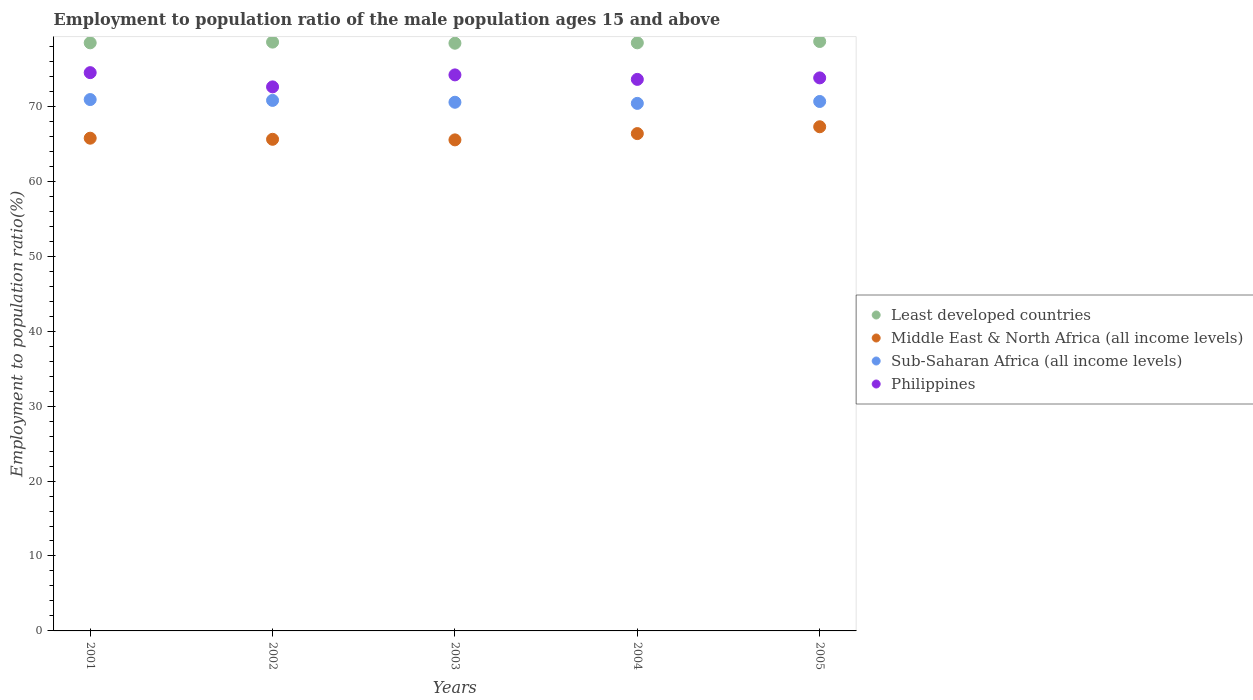Is the number of dotlines equal to the number of legend labels?
Offer a terse response. Yes. What is the employment to population ratio in Philippines in 2005?
Offer a terse response. 73.8. Across all years, what is the maximum employment to population ratio in Sub-Saharan Africa (all income levels)?
Ensure brevity in your answer.  70.91. Across all years, what is the minimum employment to population ratio in Middle East & North Africa (all income levels)?
Keep it short and to the point. 65.53. In which year was the employment to population ratio in Sub-Saharan Africa (all income levels) maximum?
Your answer should be very brief. 2001. What is the total employment to population ratio in Least developed countries in the graph?
Offer a very short reply. 392.61. What is the difference between the employment to population ratio in Least developed countries in 2001 and that in 2003?
Your answer should be compact. 0.05. What is the difference between the employment to population ratio in Middle East & North Africa (all income levels) in 2002 and the employment to population ratio in Philippines in 2001?
Offer a very short reply. -8.9. What is the average employment to population ratio in Sub-Saharan Africa (all income levels) per year?
Provide a short and direct response. 70.66. In the year 2002, what is the difference between the employment to population ratio in Middle East & North Africa (all income levels) and employment to population ratio in Sub-Saharan Africa (all income levels)?
Provide a succinct answer. -5.19. In how many years, is the employment to population ratio in Philippines greater than 66 %?
Your response must be concise. 5. What is the ratio of the employment to population ratio in Middle East & North Africa (all income levels) in 2003 to that in 2004?
Make the answer very short. 0.99. Is the employment to population ratio in Philippines in 2002 less than that in 2003?
Offer a terse response. Yes. Is the difference between the employment to population ratio in Middle East & North Africa (all income levels) in 2003 and 2004 greater than the difference between the employment to population ratio in Sub-Saharan Africa (all income levels) in 2003 and 2004?
Offer a very short reply. No. What is the difference between the highest and the second highest employment to population ratio in Philippines?
Your answer should be compact. 0.3. What is the difference between the highest and the lowest employment to population ratio in Least developed countries?
Offer a terse response. 0.23. In how many years, is the employment to population ratio in Middle East & North Africa (all income levels) greater than the average employment to population ratio in Middle East & North Africa (all income levels) taken over all years?
Give a very brief answer. 2. Is the sum of the employment to population ratio in Least developed countries in 2002 and 2004 greater than the maximum employment to population ratio in Middle East & North Africa (all income levels) across all years?
Provide a succinct answer. Yes. Is it the case that in every year, the sum of the employment to population ratio in Philippines and employment to population ratio in Middle East & North Africa (all income levels)  is greater than the sum of employment to population ratio in Least developed countries and employment to population ratio in Sub-Saharan Africa (all income levels)?
Offer a very short reply. No. Is it the case that in every year, the sum of the employment to population ratio in Philippines and employment to population ratio in Least developed countries  is greater than the employment to population ratio in Sub-Saharan Africa (all income levels)?
Your answer should be compact. Yes. Is the employment to population ratio in Philippines strictly greater than the employment to population ratio in Sub-Saharan Africa (all income levels) over the years?
Keep it short and to the point. Yes. Is the employment to population ratio in Sub-Saharan Africa (all income levels) strictly less than the employment to population ratio in Least developed countries over the years?
Make the answer very short. Yes. Does the graph contain any zero values?
Give a very brief answer. No. How many legend labels are there?
Make the answer very short. 4. How are the legend labels stacked?
Make the answer very short. Vertical. What is the title of the graph?
Your response must be concise. Employment to population ratio of the male population ages 15 and above. Does "Dominican Republic" appear as one of the legend labels in the graph?
Your answer should be compact. No. What is the label or title of the X-axis?
Give a very brief answer. Years. What is the Employment to population ratio(%) of Least developed countries in 2001?
Offer a very short reply. 78.48. What is the Employment to population ratio(%) of Middle East & North Africa (all income levels) in 2001?
Keep it short and to the point. 65.75. What is the Employment to population ratio(%) in Sub-Saharan Africa (all income levels) in 2001?
Provide a short and direct response. 70.91. What is the Employment to population ratio(%) of Philippines in 2001?
Ensure brevity in your answer.  74.5. What is the Employment to population ratio(%) in Least developed countries in 2002?
Keep it short and to the point. 78.57. What is the Employment to population ratio(%) in Middle East & North Africa (all income levels) in 2002?
Your answer should be compact. 65.6. What is the Employment to population ratio(%) in Sub-Saharan Africa (all income levels) in 2002?
Give a very brief answer. 70.8. What is the Employment to population ratio(%) in Philippines in 2002?
Ensure brevity in your answer.  72.6. What is the Employment to population ratio(%) in Least developed countries in 2003?
Offer a very short reply. 78.43. What is the Employment to population ratio(%) in Middle East & North Africa (all income levels) in 2003?
Your response must be concise. 65.53. What is the Employment to population ratio(%) in Sub-Saharan Africa (all income levels) in 2003?
Your answer should be very brief. 70.55. What is the Employment to population ratio(%) of Philippines in 2003?
Your response must be concise. 74.2. What is the Employment to population ratio(%) in Least developed countries in 2004?
Offer a terse response. 78.48. What is the Employment to population ratio(%) in Middle East & North Africa (all income levels) in 2004?
Your answer should be compact. 66.37. What is the Employment to population ratio(%) in Sub-Saharan Africa (all income levels) in 2004?
Your answer should be compact. 70.4. What is the Employment to population ratio(%) in Philippines in 2004?
Provide a succinct answer. 73.6. What is the Employment to population ratio(%) in Least developed countries in 2005?
Give a very brief answer. 78.66. What is the Employment to population ratio(%) of Middle East & North Africa (all income levels) in 2005?
Keep it short and to the point. 67.28. What is the Employment to population ratio(%) of Sub-Saharan Africa (all income levels) in 2005?
Your answer should be very brief. 70.65. What is the Employment to population ratio(%) in Philippines in 2005?
Offer a terse response. 73.8. Across all years, what is the maximum Employment to population ratio(%) in Least developed countries?
Your answer should be compact. 78.66. Across all years, what is the maximum Employment to population ratio(%) of Middle East & North Africa (all income levels)?
Provide a short and direct response. 67.28. Across all years, what is the maximum Employment to population ratio(%) in Sub-Saharan Africa (all income levels)?
Offer a terse response. 70.91. Across all years, what is the maximum Employment to population ratio(%) in Philippines?
Provide a succinct answer. 74.5. Across all years, what is the minimum Employment to population ratio(%) of Least developed countries?
Make the answer very short. 78.43. Across all years, what is the minimum Employment to population ratio(%) in Middle East & North Africa (all income levels)?
Your answer should be compact. 65.53. Across all years, what is the minimum Employment to population ratio(%) of Sub-Saharan Africa (all income levels)?
Your answer should be compact. 70.4. Across all years, what is the minimum Employment to population ratio(%) in Philippines?
Give a very brief answer. 72.6. What is the total Employment to population ratio(%) in Least developed countries in the graph?
Provide a succinct answer. 392.61. What is the total Employment to population ratio(%) of Middle East & North Africa (all income levels) in the graph?
Ensure brevity in your answer.  330.53. What is the total Employment to population ratio(%) of Sub-Saharan Africa (all income levels) in the graph?
Keep it short and to the point. 353.3. What is the total Employment to population ratio(%) in Philippines in the graph?
Make the answer very short. 368.7. What is the difference between the Employment to population ratio(%) in Least developed countries in 2001 and that in 2002?
Keep it short and to the point. -0.1. What is the difference between the Employment to population ratio(%) in Middle East & North Africa (all income levels) in 2001 and that in 2002?
Keep it short and to the point. 0.15. What is the difference between the Employment to population ratio(%) of Sub-Saharan Africa (all income levels) in 2001 and that in 2002?
Provide a succinct answer. 0.11. What is the difference between the Employment to population ratio(%) of Philippines in 2001 and that in 2002?
Keep it short and to the point. 1.9. What is the difference between the Employment to population ratio(%) of Least developed countries in 2001 and that in 2003?
Offer a terse response. 0.05. What is the difference between the Employment to population ratio(%) in Middle East & North Africa (all income levels) in 2001 and that in 2003?
Make the answer very short. 0.22. What is the difference between the Employment to population ratio(%) in Sub-Saharan Africa (all income levels) in 2001 and that in 2003?
Ensure brevity in your answer.  0.36. What is the difference between the Employment to population ratio(%) in Philippines in 2001 and that in 2003?
Ensure brevity in your answer.  0.3. What is the difference between the Employment to population ratio(%) in Least developed countries in 2001 and that in 2004?
Give a very brief answer. -0. What is the difference between the Employment to population ratio(%) in Middle East & North Africa (all income levels) in 2001 and that in 2004?
Make the answer very short. -0.61. What is the difference between the Employment to population ratio(%) in Sub-Saharan Africa (all income levels) in 2001 and that in 2004?
Make the answer very short. 0.51. What is the difference between the Employment to population ratio(%) in Least developed countries in 2001 and that in 2005?
Offer a terse response. -0.18. What is the difference between the Employment to population ratio(%) of Middle East & North Africa (all income levels) in 2001 and that in 2005?
Your response must be concise. -1.53. What is the difference between the Employment to population ratio(%) of Sub-Saharan Africa (all income levels) in 2001 and that in 2005?
Your answer should be very brief. 0.26. What is the difference between the Employment to population ratio(%) of Philippines in 2001 and that in 2005?
Make the answer very short. 0.7. What is the difference between the Employment to population ratio(%) in Least developed countries in 2002 and that in 2003?
Give a very brief answer. 0.15. What is the difference between the Employment to population ratio(%) of Middle East & North Africa (all income levels) in 2002 and that in 2003?
Make the answer very short. 0.08. What is the difference between the Employment to population ratio(%) of Sub-Saharan Africa (all income levels) in 2002 and that in 2003?
Provide a short and direct response. 0.25. What is the difference between the Employment to population ratio(%) of Least developed countries in 2002 and that in 2004?
Offer a terse response. 0.1. What is the difference between the Employment to population ratio(%) of Middle East & North Africa (all income levels) in 2002 and that in 2004?
Offer a very short reply. -0.76. What is the difference between the Employment to population ratio(%) in Sub-Saharan Africa (all income levels) in 2002 and that in 2004?
Offer a terse response. 0.4. What is the difference between the Employment to population ratio(%) of Philippines in 2002 and that in 2004?
Your answer should be very brief. -1. What is the difference between the Employment to population ratio(%) of Least developed countries in 2002 and that in 2005?
Keep it short and to the point. -0.08. What is the difference between the Employment to population ratio(%) of Middle East & North Africa (all income levels) in 2002 and that in 2005?
Keep it short and to the point. -1.67. What is the difference between the Employment to population ratio(%) in Sub-Saharan Africa (all income levels) in 2002 and that in 2005?
Provide a short and direct response. 0.14. What is the difference between the Employment to population ratio(%) of Philippines in 2002 and that in 2005?
Offer a very short reply. -1.2. What is the difference between the Employment to population ratio(%) in Least developed countries in 2003 and that in 2004?
Provide a succinct answer. -0.05. What is the difference between the Employment to population ratio(%) in Middle East & North Africa (all income levels) in 2003 and that in 2004?
Provide a succinct answer. -0.84. What is the difference between the Employment to population ratio(%) of Least developed countries in 2003 and that in 2005?
Provide a succinct answer. -0.23. What is the difference between the Employment to population ratio(%) of Middle East & North Africa (all income levels) in 2003 and that in 2005?
Offer a very short reply. -1.75. What is the difference between the Employment to population ratio(%) in Sub-Saharan Africa (all income levels) in 2003 and that in 2005?
Give a very brief answer. -0.1. What is the difference between the Employment to population ratio(%) in Philippines in 2003 and that in 2005?
Offer a very short reply. 0.4. What is the difference between the Employment to population ratio(%) in Least developed countries in 2004 and that in 2005?
Offer a terse response. -0.18. What is the difference between the Employment to population ratio(%) of Middle East & North Africa (all income levels) in 2004 and that in 2005?
Your answer should be very brief. -0.91. What is the difference between the Employment to population ratio(%) of Sub-Saharan Africa (all income levels) in 2004 and that in 2005?
Ensure brevity in your answer.  -0.25. What is the difference between the Employment to population ratio(%) in Least developed countries in 2001 and the Employment to population ratio(%) in Middle East & North Africa (all income levels) in 2002?
Your answer should be compact. 12.87. What is the difference between the Employment to population ratio(%) of Least developed countries in 2001 and the Employment to population ratio(%) of Sub-Saharan Africa (all income levels) in 2002?
Offer a terse response. 7.68. What is the difference between the Employment to population ratio(%) of Least developed countries in 2001 and the Employment to population ratio(%) of Philippines in 2002?
Offer a terse response. 5.88. What is the difference between the Employment to population ratio(%) of Middle East & North Africa (all income levels) in 2001 and the Employment to population ratio(%) of Sub-Saharan Africa (all income levels) in 2002?
Ensure brevity in your answer.  -5.04. What is the difference between the Employment to population ratio(%) of Middle East & North Africa (all income levels) in 2001 and the Employment to population ratio(%) of Philippines in 2002?
Give a very brief answer. -6.85. What is the difference between the Employment to population ratio(%) in Sub-Saharan Africa (all income levels) in 2001 and the Employment to population ratio(%) in Philippines in 2002?
Keep it short and to the point. -1.69. What is the difference between the Employment to population ratio(%) of Least developed countries in 2001 and the Employment to population ratio(%) of Middle East & North Africa (all income levels) in 2003?
Offer a very short reply. 12.95. What is the difference between the Employment to population ratio(%) in Least developed countries in 2001 and the Employment to population ratio(%) in Sub-Saharan Africa (all income levels) in 2003?
Give a very brief answer. 7.93. What is the difference between the Employment to population ratio(%) in Least developed countries in 2001 and the Employment to population ratio(%) in Philippines in 2003?
Keep it short and to the point. 4.28. What is the difference between the Employment to population ratio(%) of Middle East & North Africa (all income levels) in 2001 and the Employment to population ratio(%) of Sub-Saharan Africa (all income levels) in 2003?
Offer a terse response. -4.8. What is the difference between the Employment to population ratio(%) of Middle East & North Africa (all income levels) in 2001 and the Employment to population ratio(%) of Philippines in 2003?
Give a very brief answer. -8.45. What is the difference between the Employment to population ratio(%) in Sub-Saharan Africa (all income levels) in 2001 and the Employment to population ratio(%) in Philippines in 2003?
Ensure brevity in your answer.  -3.29. What is the difference between the Employment to population ratio(%) in Least developed countries in 2001 and the Employment to population ratio(%) in Middle East & North Africa (all income levels) in 2004?
Offer a terse response. 12.11. What is the difference between the Employment to population ratio(%) of Least developed countries in 2001 and the Employment to population ratio(%) of Sub-Saharan Africa (all income levels) in 2004?
Your answer should be very brief. 8.08. What is the difference between the Employment to population ratio(%) in Least developed countries in 2001 and the Employment to population ratio(%) in Philippines in 2004?
Your answer should be very brief. 4.88. What is the difference between the Employment to population ratio(%) in Middle East & North Africa (all income levels) in 2001 and the Employment to population ratio(%) in Sub-Saharan Africa (all income levels) in 2004?
Offer a very short reply. -4.65. What is the difference between the Employment to population ratio(%) in Middle East & North Africa (all income levels) in 2001 and the Employment to population ratio(%) in Philippines in 2004?
Provide a succinct answer. -7.85. What is the difference between the Employment to population ratio(%) of Sub-Saharan Africa (all income levels) in 2001 and the Employment to population ratio(%) of Philippines in 2004?
Ensure brevity in your answer.  -2.69. What is the difference between the Employment to population ratio(%) of Least developed countries in 2001 and the Employment to population ratio(%) of Middle East & North Africa (all income levels) in 2005?
Provide a succinct answer. 11.2. What is the difference between the Employment to population ratio(%) of Least developed countries in 2001 and the Employment to population ratio(%) of Sub-Saharan Africa (all income levels) in 2005?
Ensure brevity in your answer.  7.83. What is the difference between the Employment to population ratio(%) of Least developed countries in 2001 and the Employment to population ratio(%) of Philippines in 2005?
Make the answer very short. 4.68. What is the difference between the Employment to population ratio(%) of Middle East & North Africa (all income levels) in 2001 and the Employment to population ratio(%) of Sub-Saharan Africa (all income levels) in 2005?
Offer a terse response. -4.9. What is the difference between the Employment to population ratio(%) of Middle East & North Africa (all income levels) in 2001 and the Employment to population ratio(%) of Philippines in 2005?
Your response must be concise. -8.05. What is the difference between the Employment to population ratio(%) in Sub-Saharan Africa (all income levels) in 2001 and the Employment to population ratio(%) in Philippines in 2005?
Your answer should be very brief. -2.89. What is the difference between the Employment to population ratio(%) of Least developed countries in 2002 and the Employment to population ratio(%) of Middle East & North Africa (all income levels) in 2003?
Offer a terse response. 13.05. What is the difference between the Employment to population ratio(%) in Least developed countries in 2002 and the Employment to population ratio(%) in Sub-Saharan Africa (all income levels) in 2003?
Your answer should be compact. 8.03. What is the difference between the Employment to population ratio(%) in Least developed countries in 2002 and the Employment to population ratio(%) in Philippines in 2003?
Provide a succinct answer. 4.37. What is the difference between the Employment to population ratio(%) in Middle East & North Africa (all income levels) in 2002 and the Employment to population ratio(%) in Sub-Saharan Africa (all income levels) in 2003?
Your response must be concise. -4.94. What is the difference between the Employment to population ratio(%) of Middle East & North Africa (all income levels) in 2002 and the Employment to population ratio(%) of Philippines in 2003?
Provide a short and direct response. -8.6. What is the difference between the Employment to population ratio(%) in Sub-Saharan Africa (all income levels) in 2002 and the Employment to population ratio(%) in Philippines in 2003?
Offer a terse response. -3.4. What is the difference between the Employment to population ratio(%) of Least developed countries in 2002 and the Employment to population ratio(%) of Middle East & North Africa (all income levels) in 2004?
Make the answer very short. 12.21. What is the difference between the Employment to population ratio(%) of Least developed countries in 2002 and the Employment to population ratio(%) of Sub-Saharan Africa (all income levels) in 2004?
Make the answer very short. 8.18. What is the difference between the Employment to population ratio(%) in Least developed countries in 2002 and the Employment to population ratio(%) in Philippines in 2004?
Your response must be concise. 4.97. What is the difference between the Employment to population ratio(%) of Middle East & North Africa (all income levels) in 2002 and the Employment to population ratio(%) of Sub-Saharan Africa (all income levels) in 2004?
Make the answer very short. -4.79. What is the difference between the Employment to population ratio(%) of Middle East & North Africa (all income levels) in 2002 and the Employment to population ratio(%) of Philippines in 2004?
Make the answer very short. -8. What is the difference between the Employment to population ratio(%) of Sub-Saharan Africa (all income levels) in 2002 and the Employment to population ratio(%) of Philippines in 2004?
Your answer should be very brief. -2.8. What is the difference between the Employment to population ratio(%) in Least developed countries in 2002 and the Employment to population ratio(%) in Middle East & North Africa (all income levels) in 2005?
Provide a short and direct response. 11.3. What is the difference between the Employment to population ratio(%) of Least developed countries in 2002 and the Employment to population ratio(%) of Sub-Saharan Africa (all income levels) in 2005?
Your answer should be very brief. 7.92. What is the difference between the Employment to population ratio(%) in Least developed countries in 2002 and the Employment to population ratio(%) in Philippines in 2005?
Your response must be concise. 4.77. What is the difference between the Employment to population ratio(%) in Middle East & North Africa (all income levels) in 2002 and the Employment to population ratio(%) in Sub-Saharan Africa (all income levels) in 2005?
Provide a succinct answer. -5.05. What is the difference between the Employment to population ratio(%) of Middle East & North Africa (all income levels) in 2002 and the Employment to population ratio(%) of Philippines in 2005?
Offer a very short reply. -8.2. What is the difference between the Employment to population ratio(%) in Sub-Saharan Africa (all income levels) in 2002 and the Employment to population ratio(%) in Philippines in 2005?
Your answer should be compact. -3. What is the difference between the Employment to population ratio(%) in Least developed countries in 2003 and the Employment to population ratio(%) in Middle East & North Africa (all income levels) in 2004?
Ensure brevity in your answer.  12.06. What is the difference between the Employment to population ratio(%) of Least developed countries in 2003 and the Employment to population ratio(%) of Sub-Saharan Africa (all income levels) in 2004?
Provide a short and direct response. 8.03. What is the difference between the Employment to population ratio(%) in Least developed countries in 2003 and the Employment to population ratio(%) in Philippines in 2004?
Your response must be concise. 4.83. What is the difference between the Employment to population ratio(%) of Middle East & North Africa (all income levels) in 2003 and the Employment to population ratio(%) of Sub-Saharan Africa (all income levels) in 2004?
Provide a succinct answer. -4.87. What is the difference between the Employment to population ratio(%) of Middle East & North Africa (all income levels) in 2003 and the Employment to population ratio(%) of Philippines in 2004?
Give a very brief answer. -8.07. What is the difference between the Employment to population ratio(%) in Sub-Saharan Africa (all income levels) in 2003 and the Employment to population ratio(%) in Philippines in 2004?
Provide a succinct answer. -3.05. What is the difference between the Employment to population ratio(%) in Least developed countries in 2003 and the Employment to population ratio(%) in Middle East & North Africa (all income levels) in 2005?
Offer a very short reply. 11.15. What is the difference between the Employment to population ratio(%) in Least developed countries in 2003 and the Employment to population ratio(%) in Sub-Saharan Africa (all income levels) in 2005?
Make the answer very short. 7.78. What is the difference between the Employment to population ratio(%) in Least developed countries in 2003 and the Employment to population ratio(%) in Philippines in 2005?
Offer a very short reply. 4.63. What is the difference between the Employment to population ratio(%) in Middle East & North Africa (all income levels) in 2003 and the Employment to population ratio(%) in Sub-Saharan Africa (all income levels) in 2005?
Provide a succinct answer. -5.12. What is the difference between the Employment to population ratio(%) in Middle East & North Africa (all income levels) in 2003 and the Employment to population ratio(%) in Philippines in 2005?
Ensure brevity in your answer.  -8.27. What is the difference between the Employment to population ratio(%) in Sub-Saharan Africa (all income levels) in 2003 and the Employment to population ratio(%) in Philippines in 2005?
Give a very brief answer. -3.25. What is the difference between the Employment to population ratio(%) in Least developed countries in 2004 and the Employment to population ratio(%) in Middle East & North Africa (all income levels) in 2005?
Your response must be concise. 11.2. What is the difference between the Employment to population ratio(%) of Least developed countries in 2004 and the Employment to population ratio(%) of Sub-Saharan Africa (all income levels) in 2005?
Make the answer very short. 7.83. What is the difference between the Employment to population ratio(%) of Least developed countries in 2004 and the Employment to population ratio(%) of Philippines in 2005?
Your answer should be very brief. 4.68. What is the difference between the Employment to population ratio(%) in Middle East & North Africa (all income levels) in 2004 and the Employment to population ratio(%) in Sub-Saharan Africa (all income levels) in 2005?
Offer a very short reply. -4.29. What is the difference between the Employment to population ratio(%) of Middle East & North Africa (all income levels) in 2004 and the Employment to population ratio(%) of Philippines in 2005?
Your answer should be compact. -7.43. What is the difference between the Employment to population ratio(%) of Sub-Saharan Africa (all income levels) in 2004 and the Employment to population ratio(%) of Philippines in 2005?
Ensure brevity in your answer.  -3.4. What is the average Employment to population ratio(%) of Least developed countries per year?
Provide a succinct answer. 78.52. What is the average Employment to population ratio(%) in Middle East & North Africa (all income levels) per year?
Provide a short and direct response. 66.11. What is the average Employment to population ratio(%) of Sub-Saharan Africa (all income levels) per year?
Offer a terse response. 70.66. What is the average Employment to population ratio(%) of Philippines per year?
Your answer should be compact. 73.74. In the year 2001, what is the difference between the Employment to population ratio(%) in Least developed countries and Employment to population ratio(%) in Middle East & North Africa (all income levels)?
Your answer should be compact. 12.73. In the year 2001, what is the difference between the Employment to population ratio(%) of Least developed countries and Employment to population ratio(%) of Sub-Saharan Africa (all income levels)?
Keep it short and to the point. 7.57. In the year 2001, what is the difference between the Employment to population ratio(%) of Least developed countries and Employment to population ratio(%) of Philippines?
Give a very brief answer. 3.98. In the year 2001, what is the difference between the Employment to population ratio(%) in Middle East & North Africa (all income levels) and Employment to population ratio(%) in Sub-Saharan Africa (all income levels)?
Your answer should be compact. -5.16. In the year 2001, what is the difference between the Employment to population ratio(%) of Middle East & North Africa (all income levels) and Employment to population ratio(%) of Philippines?
Provide a succinct answer. -8.75. In the year 2001, what is the difference between the Employment to population ratio(%) in Sub-Saharan Africa (all income levels) and Employment to population ratio(%) in Philippines?
Give a very brief answer. -3.59. In the year 2002, what is the difference between the Employment to population ratio(%) of Least developed countries and Employment to population ratio(%) of Middle East & North Africa (all income levels)?
Your answer should be compact. 12.97. In the year 2002, what is the difference between the Employment to population ratio(%) in Least developed countries and Employment to population ratio(%) in Sub-Saharan Africa (all income levels)?
Ensure brevity in your answer.  7.78. In the year 2002, what is the difference between the Employment to population ratio(%) of Least developed countries and Employment to population ratio(%) of Philippines?
Your answer should be very brief. 5.97. In the year 2002, what is the difference between the Employment to population ratio(%) in Middle East & North Africa (all income levels) and Employment to population ratio(%) in Sub-Saharan Africa (all income levels)?
Provide a succinct answer. -5.19. In the year 2002, what is the difference between the Employment to population ratio(%) in Middle East & North Africa (all income levels) and Employment to population ratio(%) in Philippines?
Offer a very short reply. -7. In the year 2002, what is the difference between the Employment to population ratio(%) of Sub-Saharan Africa (all income levels) and Employment to population ratio(%) of Philippines?
Offer a terse response. -1.8. In the year 2003, what is the difference between the Employment to population ratio(%) of Least developed countries and Employment to population ratio(%) of Middle East & North Africa (all income levels)?
Your answer should be very brief. 12.9. In the year 2003, what is the difference between the Employment to population ratio(%) in Least developed countries and Employment to population ratio(%) in Sub-Saharan Africa (all income levels)?
Ensure brevity in your answer.  7.88. In the year 2003, what is the difference between the Employment to population ratio(%) in Least developed countries and Employment to population ratio(%) in Philippines?
Give a very brief answer. 4.23. In the year 2003, what is the difference between the Employment to population ratio(%) in Middle East & North Africa (all income levels) and Employment to population ratio(%) in Sub-Saharan Africa (all income levels)?
Your answer should be compact. -5.02. In the year 2003, what is the difference between the Employment to population ratio(%) in Middle East & North Africa (all income levels) and Employment to population ratio(%) in Philippines?
Provide a succinct answer. -8.67. In the year 2003, what is the difference between the Employment to population ratio(%) in Sub-Saharan Africa (all income levels) and Employment to population ratio(%) in Philippines?
Keep it short and to the point. -3.65. In the year 2004, what is the difference between the Employment to population ratio(%) of Least developed countries and Employment to population ratio(%) of Middle East & North Africa (all income levels)?
Offer a very short reply. 12.11. In the year 2004, what is the difference between the Employment to population ratio(%) of Least developed countries and Employment to population ratio(%) of Sub-Saharan Africa (all income levels)?
Your answer should be compact. 8.08. In the year 2004, what is the difference between the Employment to population ratio(%) of Least developed countries and Employment to population ratio(%) of Philippines?
Offer a very short reply. 4.88. In the year 2004, what is the difference between the Employment to population ratio(%) of Middle East & North Africa (all income levels) and Employment to population ratio(%) of Sub-Saharan Africa (all income levels)?
Your response must be concise. -4.03. In the year 2004, what is the difference between the Employment to population ratio(%) in Middle East & North Africa (all income levels) and Employment to population ratio(%) in Philippines?
Provide a succinct answer. -7.23. In the year 2004, what is the difference between the Employment to population ratio(%) of Sub-Saharan Africa (all income levels) and Employment to population ratio(%) of Philippines?
Make the answer very short. -3.2. In the year 2005, what is the difference between the Employment to population ratio(%) of Least developed countries and Employment to population ratio(%) of Middle East & North Africa (all income levels)?
Make the answer very short. 11.38. In the year 2005, what is the difference between the Employment to population ratio(%) in Least developed countries and Employment to population ratio(%) in Sub-Saharan Africa (all income levels)?
Your answer should be compact. 8. In the year 2005, what is the difference between the Employment to population ratio(%) of Least developed countries and Employment to population ratio(%) of Philippines?
Your answer should be compact. 4.86. In the year 2005, what is the difference between the Employment to population ratio(%) in Middle East & North Africa (all income levels) and Employment to population ratio(%) in Sub-Saharan Africa (all income levels)?
Make the answer very short. -3.37. In the year 2005, what is the difference between the Employment to population ratio(%) in Middle East & North Africa (all income levels) and Employment to population ratio(%) in Philippines?
Your response must be concise. -6.52. In the year 2005, what is the difference between the Employment to population ratio(%) in Sub-Saharan Africa (all income levels) and Employment to population ratio(%) in Philippines?
Give a very brief answer. -3.15. What is the ratio of the Employment to population ratio(%) of Middle East & North Africa (all income levels) in 2001 to that in 2002?
Your answer should be very brief. 1. What is the ratio of the Employment to population ratio(%) of Sub-Saharan Africa (all income levels) in 2001 to that in 2002?
Make the answer very short. 1. What is the ratio of the Employment to population ratio(%) of Philippines in 2001 to that in 2002?
Give a very brief answer. 1.03. What is the ratio of the Employment to population ratio(%) in Least developed countries in 2001 to that in 2003?
Provide a short and direct response. 1. What is the ratio of the Employment to population ratio(%) in Middle East & North Africa (all income levels) in 2001 to that in 2003?
Make the answer very short. 1. What is the ratio of the Employment to population ratio(%) in Least developed countries in 2001 to that in 2004?
Your answer should be very brief. 1. What is the ratio of the Employment to population ratio(%) in Sub-Saharan Africa (all income levels) in 2001 to that in 2004?
Provide a succinct answer. 1.01. What is the ratio of the Employment to population ratio(%) of Philippines in 2001 to that in 2004?
Your answer should be compact. 1.01. What is the ratio of the Employment to population ratio(%) of Middle East & North Africa (all income levels) in 2001 to that in 2005?
Your answer should be very brief. 0.98. What is the ratio of the Employment to population ratio(%) in Philippines in 2001 to that in 2005?
Your answer should be compact. 1.01. What is the ratio of the Employment to population ratio(%) of Least developed countries in 2002 to that in 2003?
Ensure brevity in your answer.  1. What is the ratio of the Employment to population ratio(%) of Middle East & North Africa (all income levels) in 2002 to that in 2003?
Provide a short and direct response. 1. What is the ratio of the Employment to population ratio(%) of Sub-Saharan Africa (all income levels) in 2002 to that in 2003?
Keep it short and to the point. 1. What is the ratio of the Employment to population ratio(%) of Philippines in 2002 to that in 2003?
Ensure brevity in your answer.  0.98. What is the ratio of the Employment to population ratio(%) of Middle East & North Africa (all income levels) in 2002 to that in 2004?
Ensure brevity in your answer.  0.99. What is the ratio of the Employment to population ratio(%) of Sub-Saharan Africa (all income levels) in 2002 to that in 2004?
Provide a succinct answer. 1.01. What is the ratio of the Employment to population ratio(%) of Philippines in 2002 to that in 2004?
Provide a succinct answer. 0.99. What is the ratio of the Employment to population ratio(%) in Least developed countries in 2002 to that in 2005?
Your answer should be compact. 1. What is the ratio of the Employment to population ratio(%) in Middle East & North Africa (all income levels) in 2002 to that in 2005?
Give a very brief answer. 0.98. What is the ratio of the Employment to population ratio(%) in Philippines in 2002 to that in 2005?
Your answer should be compact. 0.98. What is the ratio of the Employment to population ratio(%) in Least developed countries in 2003 to that in 2004?
Ensure brevity in your answer.  1. What is the ratio of the Employment to population ratio(%) of Middle East & North Africa (all income levels) in 2003 to that in 2004?
Give a very brief answer. 0.99. What is the ratio of the Employment to population ratio(%) of Philippines in 2003 to that in 2004?
Provide a succinct answer. 1.01. What is the ratio of the Employment to population ratio(%) of Middle East & North Africa (all income levels) in 2003 to that in 2005?
Your response must be concise. 0.97. What is the ratio of the Employment to population ratio(%) in Sub-Saharan Africa (all income levels) in 2003 to that in 2005?
Provide a short and direct response. 1. What is the ratio of the Employment to population ratio(%) of Philippines in 2003 to that in 2005?
Keep it short and to the point. 1.01. What is the ratio of the Employment to population ratio(%) of Least developed countries in 2004 to that in 2005?
Make the answer very short. 1. What is the ratio of the Employment to population ratio(%) in Middle East & North Africa (all income levels) in 2004 to that in 2005?
Your answer should be very brief. 0.99. What is the difference between the highest and the second highest Employment to population ratio(%) in Least developed countries?
Offer a very short reply. 0.08. What is the difference between the highest and the second highest Employment to population ratio(%) of Middle East & North Africa (all income levels)?
Keep it short and to the point. 0.91. What is the difference between the highest and the second highest Employment to population ratio(%) of Sub-Saharan Africa (all income levels)?
Offer a terse response. 0.11. What is the difference between the highest and the lowest Employment to population ratio(%) of Least developed countries?
Keep it short and to the point. 0.23. What is the difference between the highest and the lowest Employment to population ratio(%) in Middle East & North Africa (all income levels)?
Provide a succinct answer. 1.75. What is the difference between the highest and the lowest Employment to population ratio(%) of Sub-Saharan Africa (all income levels)?
Your answer should be very brief. 0.51. 